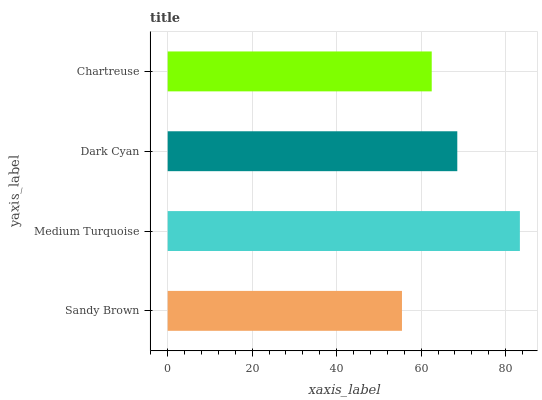Is Sandy Brown the minimum?
Answer yes or no. Yes. Is Medium Turquoise the maximum?
Answer yes or no. Yes. Is Dark Cyan the minimum?
Answer yes or no. No. Is Dark Cyan the maximum?
Answer yes or no. No. Is Medium Turquoise greater than Dark Cyan?
Answer yes or no. Yes. Is Dark Cyan less than Medium Turquoise?
Answer yes or no. Yes. Is Dark Cyan greater than Medium Turquoise?
Answer yes or no. No. Is Medium Turquoise less than Dark Cyan?
Answer yes or no. No. Is Dark Cyan the high median?
Answer yes or no. Yes. Is Chartreuse the low median?
Answer yes or no. Yes. Is Medium Turquoise the high median?
Answer yes or no. No. Is Medium Turquoise the low median?
Answer yes or no. No. 